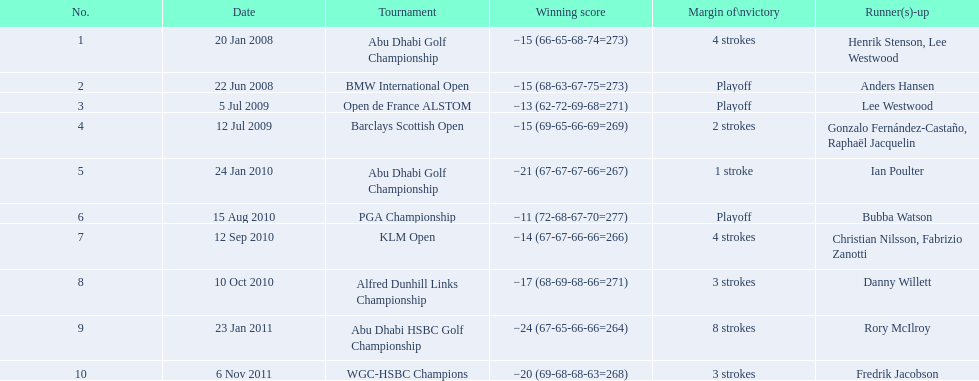What was martin kaymer's stroke count during the klm open? 4 strokes. How many strokes happened at the abu dhabi golf championship? 4 strokes. What was the difference in stroke count between the klm and the barclays open? 2 strokes. 